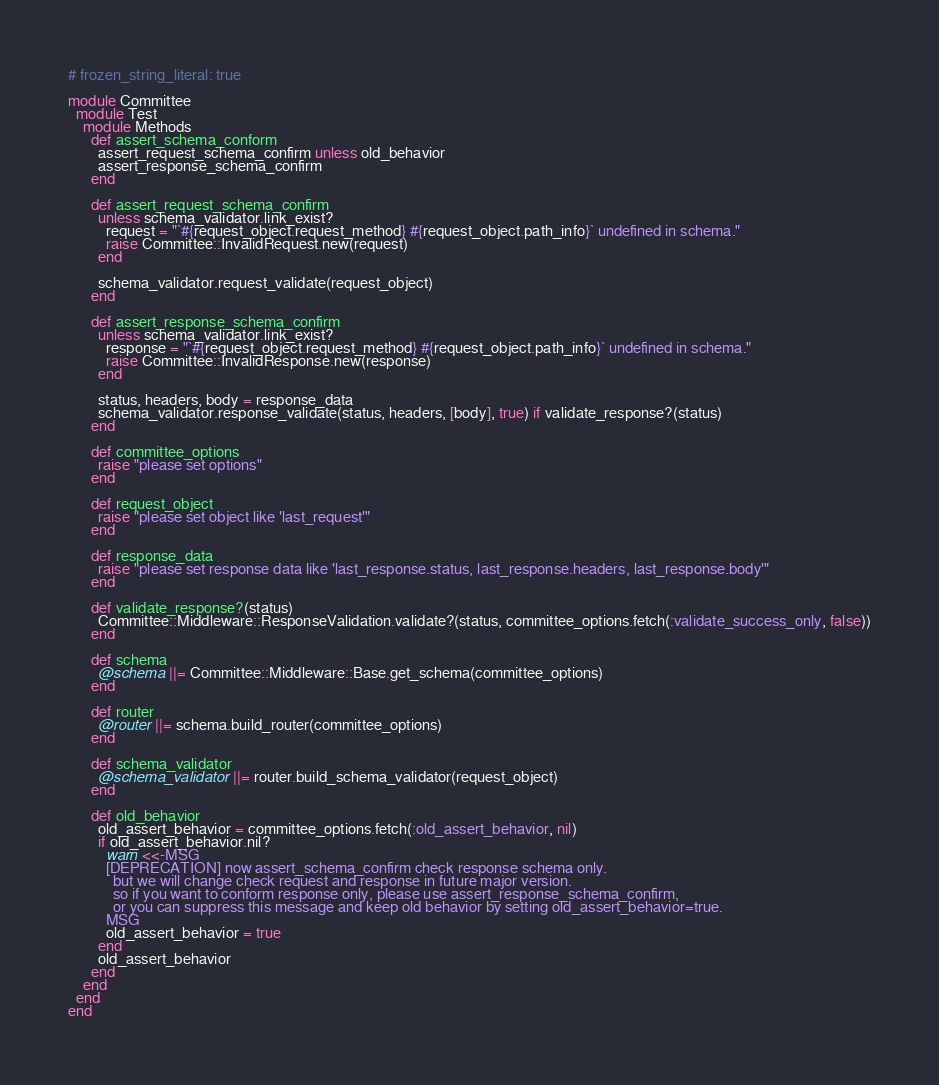Convert code to text. <code><loc_0><loc_0><loc_500><loc_500><_Ruby_># frozen_string_literal: true

module Committee
  module Test
    module Methods
      def assert_schema_conform
        assert_request_schema_confirm unless old_behavior
        assert_response_schema_confirm
      end

      def assert_request_schema_confirm
        unless schema_validator.link_exist?
          request = "`#{request_object.request_method} #{request_object.path_info}` undefined in schema."
          raise Committee::InvalidRequest.new(request)
        end

        schema_validator.request_validate(request_object)
      end

      def assert_response_schema_confirm
        unless schema_validator.link_exist?
          response = "`#{request_object.request_method} #{request_object.path_info}` undefined in schema."
          raise Committee::InvalidResponse.new(response)
        end

        status, headers, body = response_data
        schema_validator.response_validate(status, headers, [body], true) if validate_response?(status)
      end

      def committee_options
        raise "please set options"
      end

      def request_object
        raise "please set object like 'last_request'"
      end

      def response_data
        raise "please set response data like 'last_response.status, last_response.headers, last_response.body'"
      end

      def validate_response?(status)
        Committee::Middleware::ResponseValidation.validate?(status, committee_options.fetch(:validate_success_only, false))
      end

      def schema
        @schema ||= Committee::Middleware::Base.get_schema(committee_options)
      end

      def router
        @router ||= schema.build_router(committee_options)
      end

      def schema_validator
        @schema_validator ||= router.build_schema_validator(request_object)
      end

      def old_behavior
        old_assert_behavior = committee_options.fetch(:old_assert_behavior, nil)
        if old_assert_behavior.nil?
          warn <<-MSG
          [DEPRECATION] now assert_schema_confirm check response schema only.
            but we will change check request and response in future major version.
            so if you want to conform response only, please use assert_response_schema_confirm,
            or you can suppress this message and keep old behavior by setting old_assert_behavior=true.
          MSG
          old_assert_behavior = true
        end
        old_assert_behavior
      end
    end
  end
end
</code> 